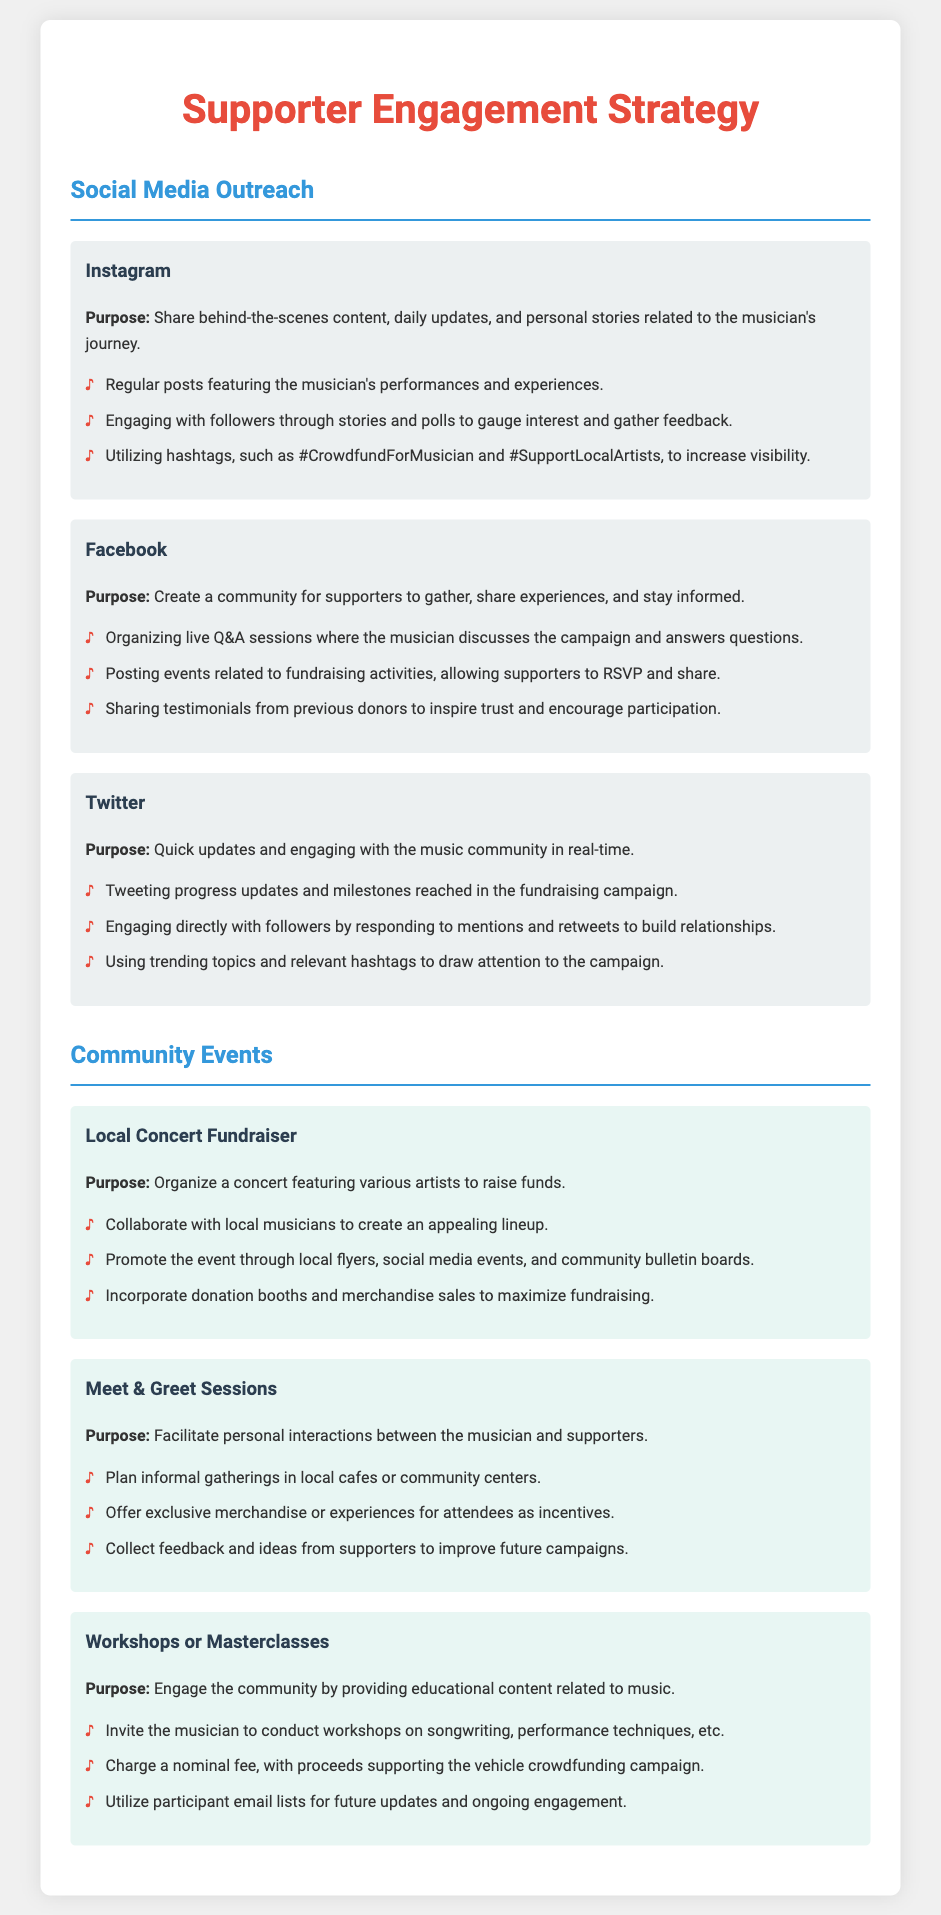What is the purpose of the Instagram outreach? The purpose of the Instagram outreach is to share behind-the-scenes content, daily updates, and personal stories related to the musician's journey.
Answer: Share behind-the-scenes content How many platforms are detailed under Social Media Outreach? The Social Media Outreach section lists three platforms: Instagram, Facebook, and Twitter.
Answer: Three What is the main activity planned for the Local Concert Fundraiser? The main activity planned for the Local Concert Fundraiser is to organize a concert featuring various artists to raise funds.
Answer: Organize a concert What type of sessions are planned for personal interactions? The type of sessions planned for personal interactions is Meet & Greet Sessions.
Answer: Meet & Greet Sessions How can community members engage with the musician through workshops? Community members can engage with the musician through workshops or masterclasses by participating in educational content related to music.
Answer: Workshops or masterclasses What is the main goal of utilizing events on Facebook? The main goal of utilizing events on Facebook is to allow supporters to RSVP and share.
Answer: Allow supporters to RSVP What incentive is offered during Meet & Greet Sessions? Exclusive merchandise or experiences are offered as incentives during Meet & Greet Sessions.
Answer: Exclusive merchandise What pricing strategy is employed for workshops? The pricing strategy employed for workshops is to charge a nominal fee.
Answer: Charge a nominal fee 